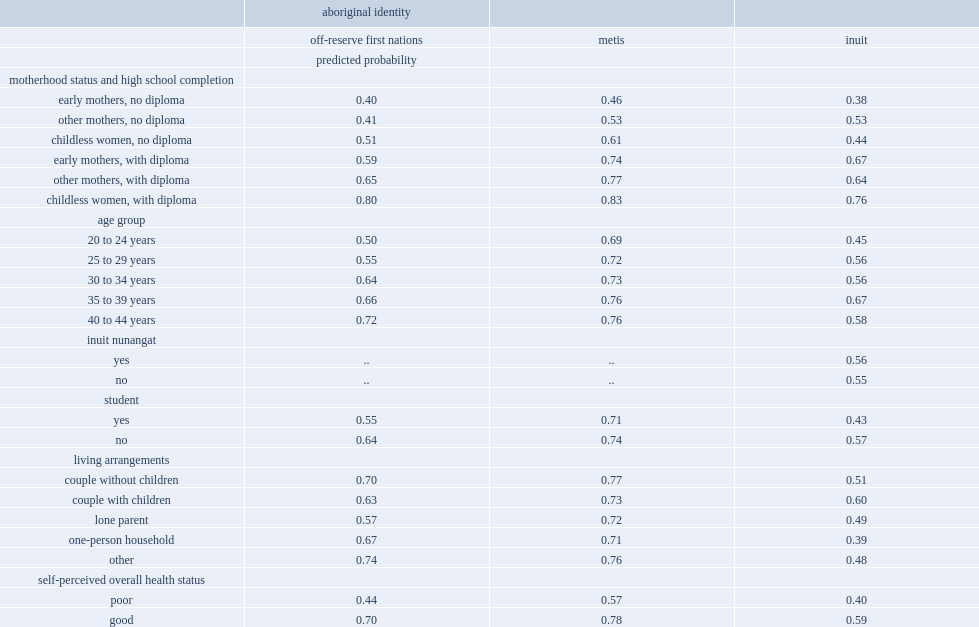What is the likelihood of being employed among off-reserve first nations mothers without a high school diploma who become mothers in their teens? 0.4. What is the likelihood of being employed among off-reserve first nations mothers without a high school diploma who become mothers later in life? 0.41. What is the likelihood of being employed among off-reserve first nations early mothers with a diploma? 0.59. What is the likelihood of being employed among inuit women, those who have at least a high school diploma and who become mothers in their teenage years? 0.67. Which kind of inuit women have higher probability to be employed, women who had at least a high school diploma and who became mothers in their teenage years or early mothers who did not complete high school? Early mothers, with diploma. Which kind of inuit women are less likely to be employed, women without a diploma and without children or women who completed high school and were early mothers? Childless women, no diploma. 